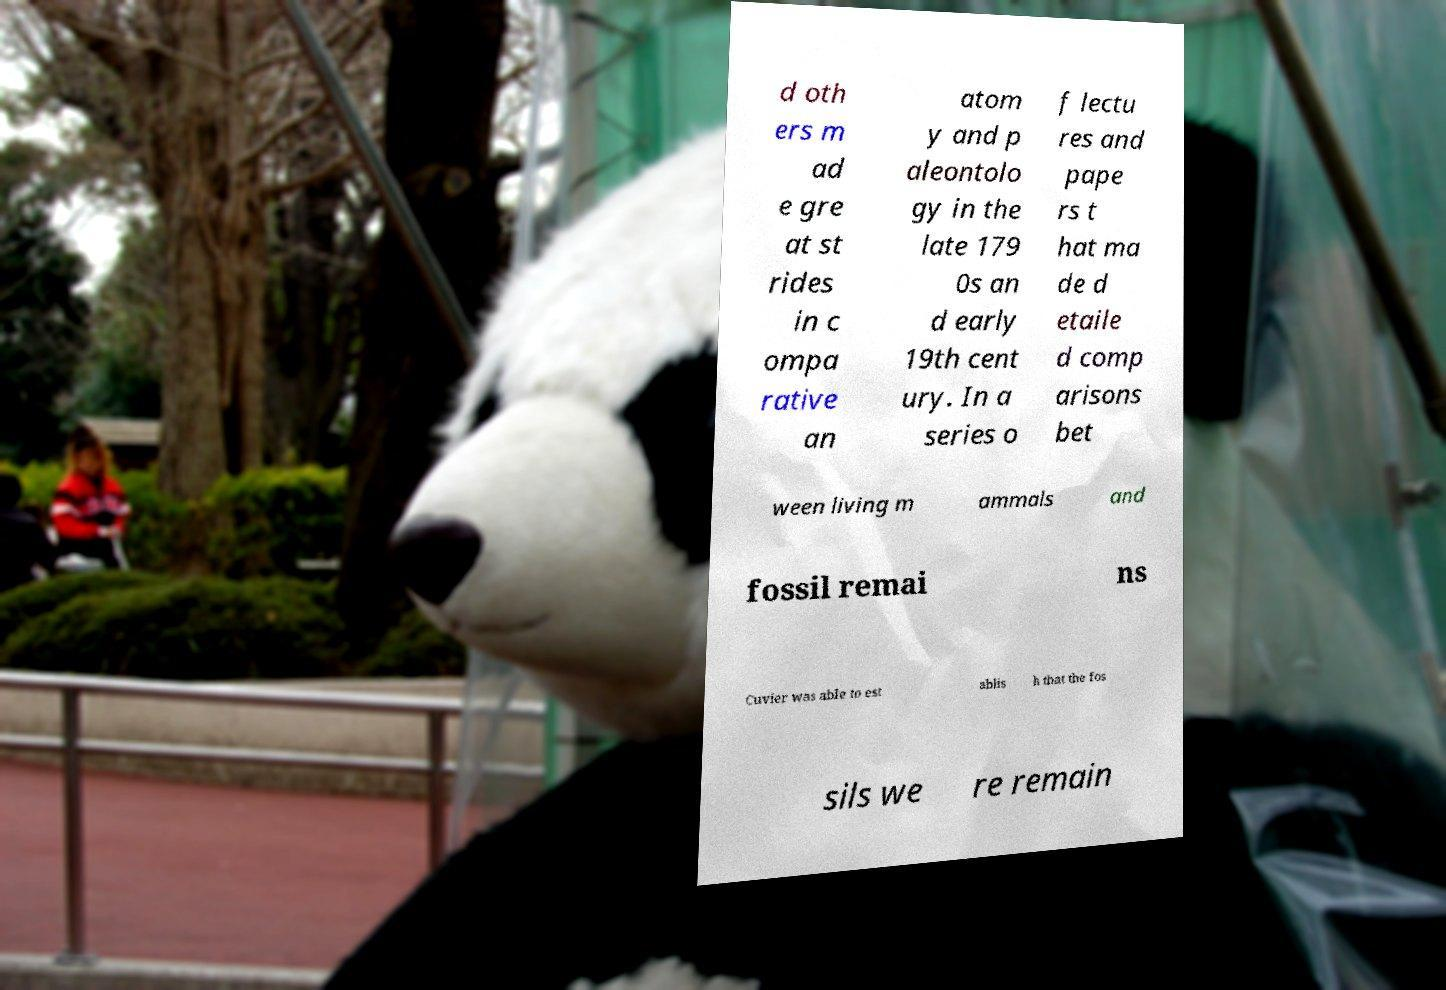There's text embedded in this image that I need extracted. Can you transcribe it verbatim? d oth ers m ad e gre at st rides in c ompa rative an atom y and p aleontolo gy in the late 179 0s an d early 19th cent ury. In a series o f lectu res and pape rs t hat ma de d etaile d comp arisons bet ween living m ammals and fossil remai ns Cuvier was able to est ablis h that the fos sils we re remain 